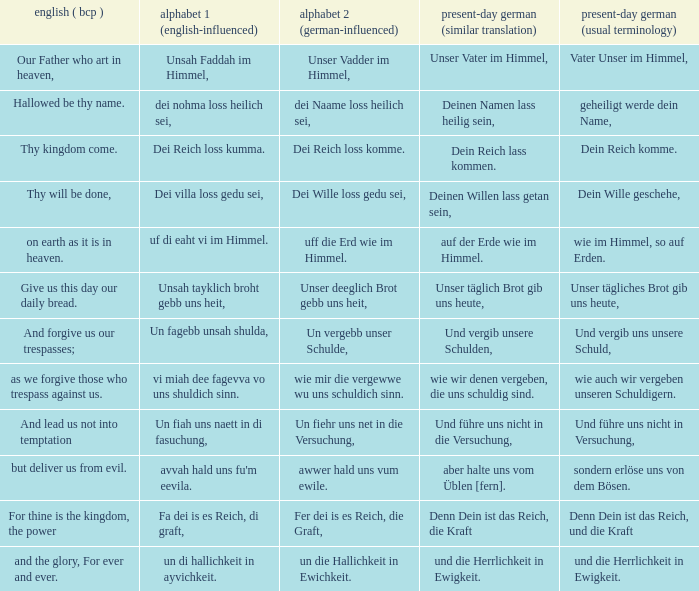What is the english (bcp) phrase "for thine is the kingdom, the power" in modern german with standard wording? Denn Dein ist das Reich, und die Kraft. 